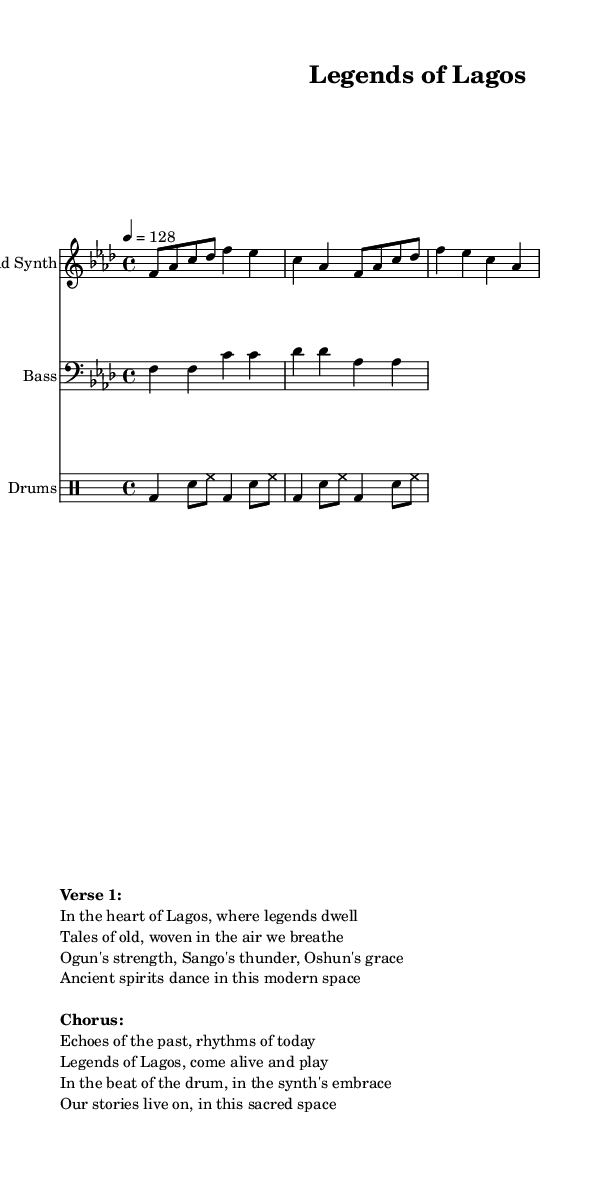What is the key signature of this music? The key signature is F minor, which has four flats: B, E, A, and D. This is indicated at the beginning of the staff.
Answer: F minor What is the time signature of this music? The time signature is 4/4, meaning there are four beats in each measure and the quarter note receives one beat. This is also indicated at the beginning of the music.
Answer: 4/4 What is the tempo marking for this piece? The tempo marking is 128 beats per minute, which is indicated in the score with a tempo directive. This indicates the speed at which the piece should be played.
Answer: 128 How many measures are there in the lead synth part? The lead synth part consists of four measures, as visually indicated by the grouping of the notes into segments that correspond to the measure lines.
Answer: Four Which instrument plays the bass line? The bass line is played by the instrument labeled "Bass," specified in the score, and it is written in the bass clef.
Answer: Bass What rhythmic pattern do the drums follow? The drums follow a pattern that alternates between bass drum and snare drum, combining them with hi-hat strikes, characterized as a common house rhythm.
Answer: Bass and snare What themes are presented in the lyrics? The lyrics present themes of Nigerian folklore and legends, focusing on deities and spirits from Yoruba culture, expressed through rich imagery.
Answer: Folklore and legends 